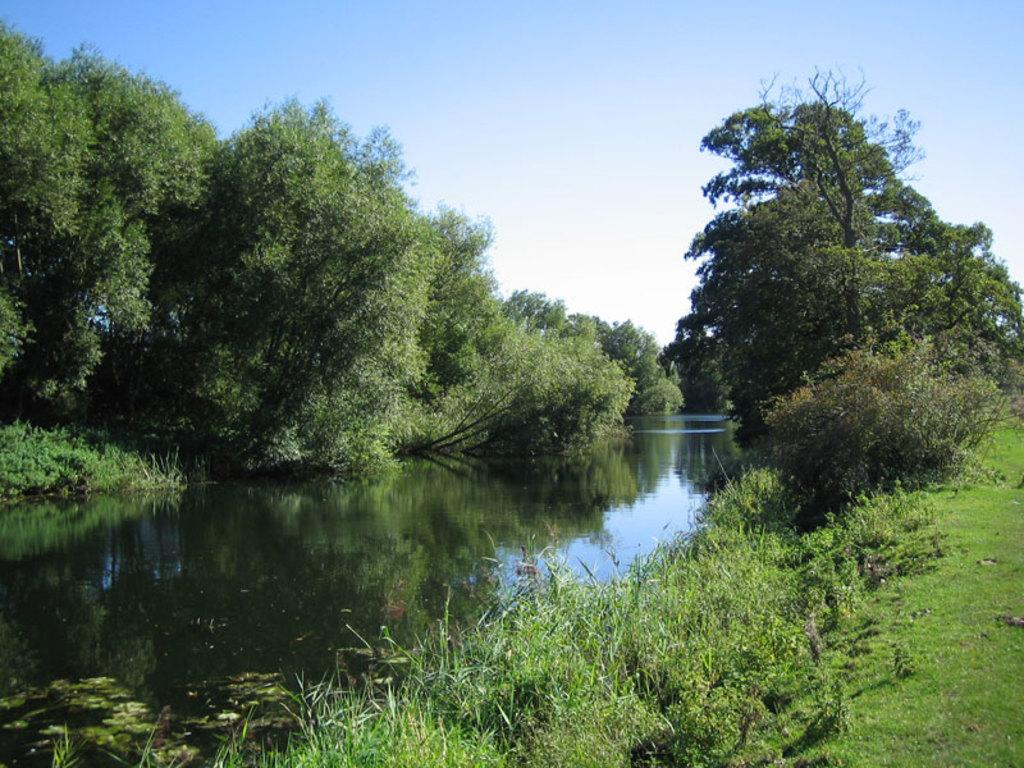What type of natural environment is visible in the image? There is water, grass, and trees visible in the image. What can be seen in the sky in the background of the image? The sky is visible in the background of the image. How many kitties are playing with the dolls in the image? There are no kitties or dolls present in the image. What is the monetary value of the trees in the image? The image does not provide any information about the monetary value of the trees. 